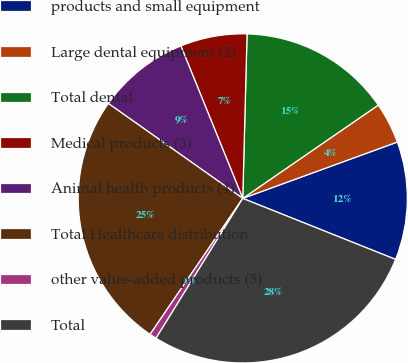Convert chart. <chart><loc_0><loc_0><loc_500><loc_500><pie_chart><fcel>products and small equipment<fcel>Large dental equipment (2)<fcel>Total dental<fcel>Medical products (3)<fcel>Animal health products (4)<fcel>Total Healthcare distribution<fcel>other value-added products (5)<fcel>Total<nl><fcel>11.61%<fcel>4.03%<fcel>14.99%<fcel>6.55%<fcel>9.08%<fcel>25.26%<fcel>0.69%<fcel>27.79%<nl></chart> 